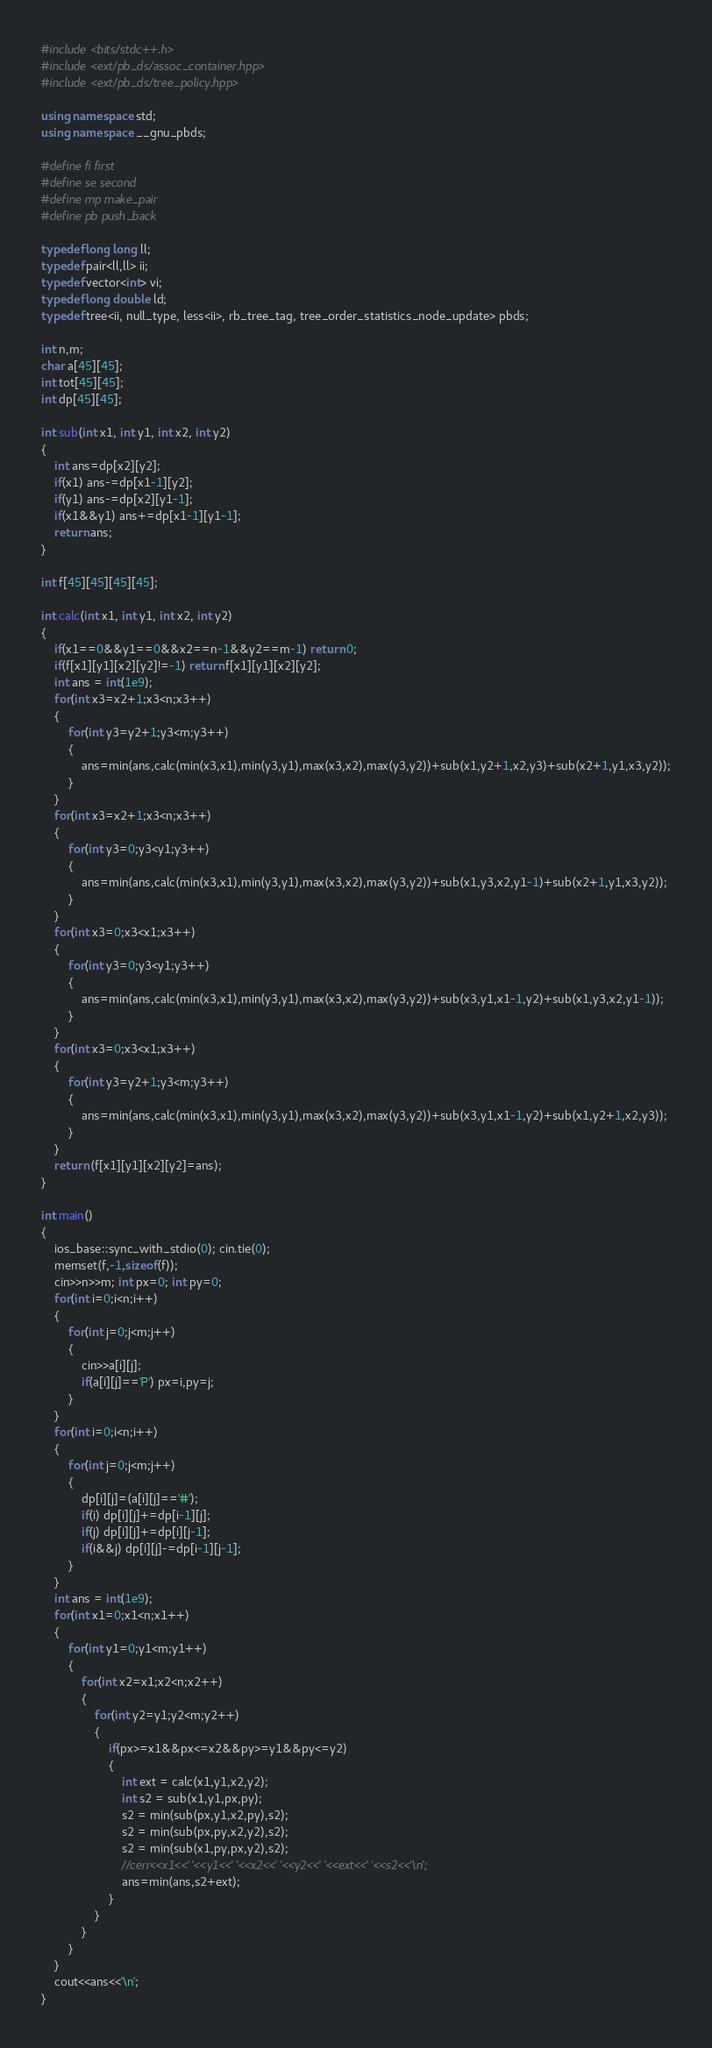<code> <loc_0><loc_0><loc_500><loc_500><_C++_>#include <bits/stdc++.h>
#include <ext/pb_ds/assoc_container.hpp>
#include <ext/pb_ds/tree_policy.hpp>

using namespace std;
using namespace __gnu_pbds;
 
#define fi first
#define se second
#define mp make_pair
#define pb push_back
 
typedef long long ll;
typedef pair<ll,ll> ii;
typedef vector<int> vi;
typedef long double ld; 
typedef tree<ii, null_type, less<ii>, rb_tree_tag, tree_order_statistics_node_update> pbds;

int n,m; 
char a[45][45];
int tot[45][45];
int dp[45][45];

int sub(int x1, int y1, int x2, int y2)
{
	int ans=dp[x2][y2];
	if(x1) ans-=dp[x1-1][y2];
	if(y1) ans-=dp[x2][y1-1];
	if(x1&&y1) ans+=dp[x1-1][y1-1];
	return ans;
}

int f[45][45][45][45];

int calc(int x1, int y1, int x2, int y2)
{
	if(x1==0&&y1==0&&x2==n-1&&y2==m-1) return 0;
	if(f[x1][y1][x2][y2]!=-1) return f[x1][y1][x2][y2];
	int ans = int(1e9);
	for(int x3=x2+1;x3<n;x3++)
	{
		for(int y3=y2+1;y3<m;y3++)
		{
			ans=min(ans,calc(min(x3,x1),min(y3,y1),max(x3,x2),max(y3,y2))+sub(x1,y2+1,x2,y3)+sub(x2+1,y1,x3,y2));
		}
	}
	for(int x3=x2+1;x3<n;x3++)
	{
		for(int y3=0;y3<y1;y3++)
		{
			ans=min(ans,calc(min(x3,x1),min(y3,y1),max(x3,x2),max(y3,y2))+sub(x1,y3,x2,y1-1)+sub(x2+1,y1,x3,y2));
		}
	}
	for(int x3=0;x3<x1;x3++)
	{
		for(int y3=0;y3<y1;y3++)
		{
			ans=min(ans,calc(min(x3,x1),min(y3,y1),max(x3,x2),max(y3,y2))+sub(x3,y1,x1-1,y2)+sub(x1,y3,x2,y1-1));
		}
	}
	for(int x3=0;x3<x1;x3++)
	{
		for(int y3=y2+1;y3<m;y3++)
		{
			ans=min(ans,calc(min(x3,x1),min(y3,y1),max(x3,x2),max(y3,y2))+sub(x3,y1,x1-1,y2)+sub(x1,y2+1,x2,y3));
		}
	}
	return (f[x1][y1][x2][y2]=ans);
}

int main()
{
	ios_base::sync_with_stdio(0); cin.tie(0);
	memset(f,-1,sizeof(f));
	cin>>n>>m; int px=0; int py=0;
	for(int i=0;i<n;i++)
	{
		for(int j=0;j<m;j++)
		{
			cin>>a[i][j];
			if(a[i][j]=='P') px=i,py=j;
		}
	}
	for(int i=0;i<n;i++)
	{
		for(int j=0;j<m;j++)
		{
			dp[i][j]=(a[i][j]=='#');
			if(i) dp[i][j]+=dp[i-1][j];
			if(j) dp[i][j]+=dp[i][j-1];
			if(i&&j) dp[i][j]-=dp[i-1][j-1];
		}
	}
	int ans = int(1e9);
	for(int x1=0;x1<n;x1++)
	{
		for(int y1=0;y1<m;y1++)
		{
			for(int x2=x1;x2<n;x2++)
			{
				for(int y2=y1;y2<m;y2++)
				{
					if(px>=x1&&px<=x2&&py>=y1&&py<=y2)
					{
						int ext = calc(x1,y1,x2,y2);
						int s2 = sub(x1,y1,px,py);
						s2 = min(sub(px,y1,x2,py),s2);
						s2 = min(sub(px,py,x2,y2),s2);
						s2 = min(sub(x1,py,px,y2),s2);
						//cerr<<x1<<' '<<y1<<' '<<x2<<' '<<y2<<' '<<ext<<' '<<s2<<'\n';
						ans=min(ans,s2+ext);
					}
				}
			}
		}
	}
	cout<<ans<<'\n';
}
</code> 